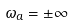<formula> <loc_0><loc_0><loc_500><loc_500>\omega _ { a } = \pm \infty</formula> 